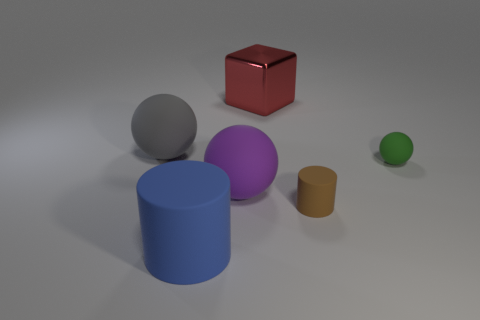Add 4 brown matte objects. How many objects exist? 10 Subtract all cylinders. How many objects are left? 4 Add 4 blue cylinders. How many blue cylinders are left? 5 Add 1 green matte balls. How many green matte balls exist? 2 Subtract 1 red blocks. How many objects are left? 5 Subtract all small cylinders. Subtract all big cubes. How many objects are left? 4 